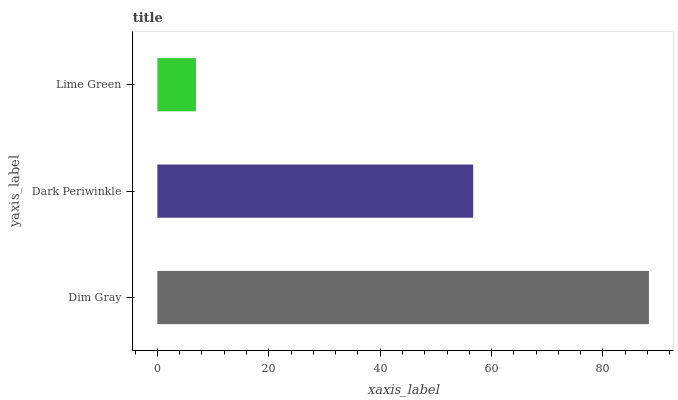Is Lime Green the minimum?
Answer yes or no. Yes. Is Dim Gray the maximum?
Answer yes or no. Yes. Is Dark Periwinkle the minimum?
Answer yes or no. No. Is Dark Periwinkle the maximum?
Answer yes or no. No. Is Dim Gray greater than Dark Periwinkle?
Answer yes or no. Yes. Is Dark Periwinkle less than Dim Gray?
Answer yes or no. Yes. Is Dark Periwinkle greater than Dim Gray?
Answer yes or no. No. Is Dim Gray less than Dark Periwinkle?
Answer yes or no. No. Is Dark Periwinkle the high median?
Answer yes or no. Yes. Is Dark Periwinkle the low median?
Answer yes or no. Yes. Is Dim Gray the high median?
Answer yes or no. No. Is Lime Green the low median?
Answer yes or no. No. 